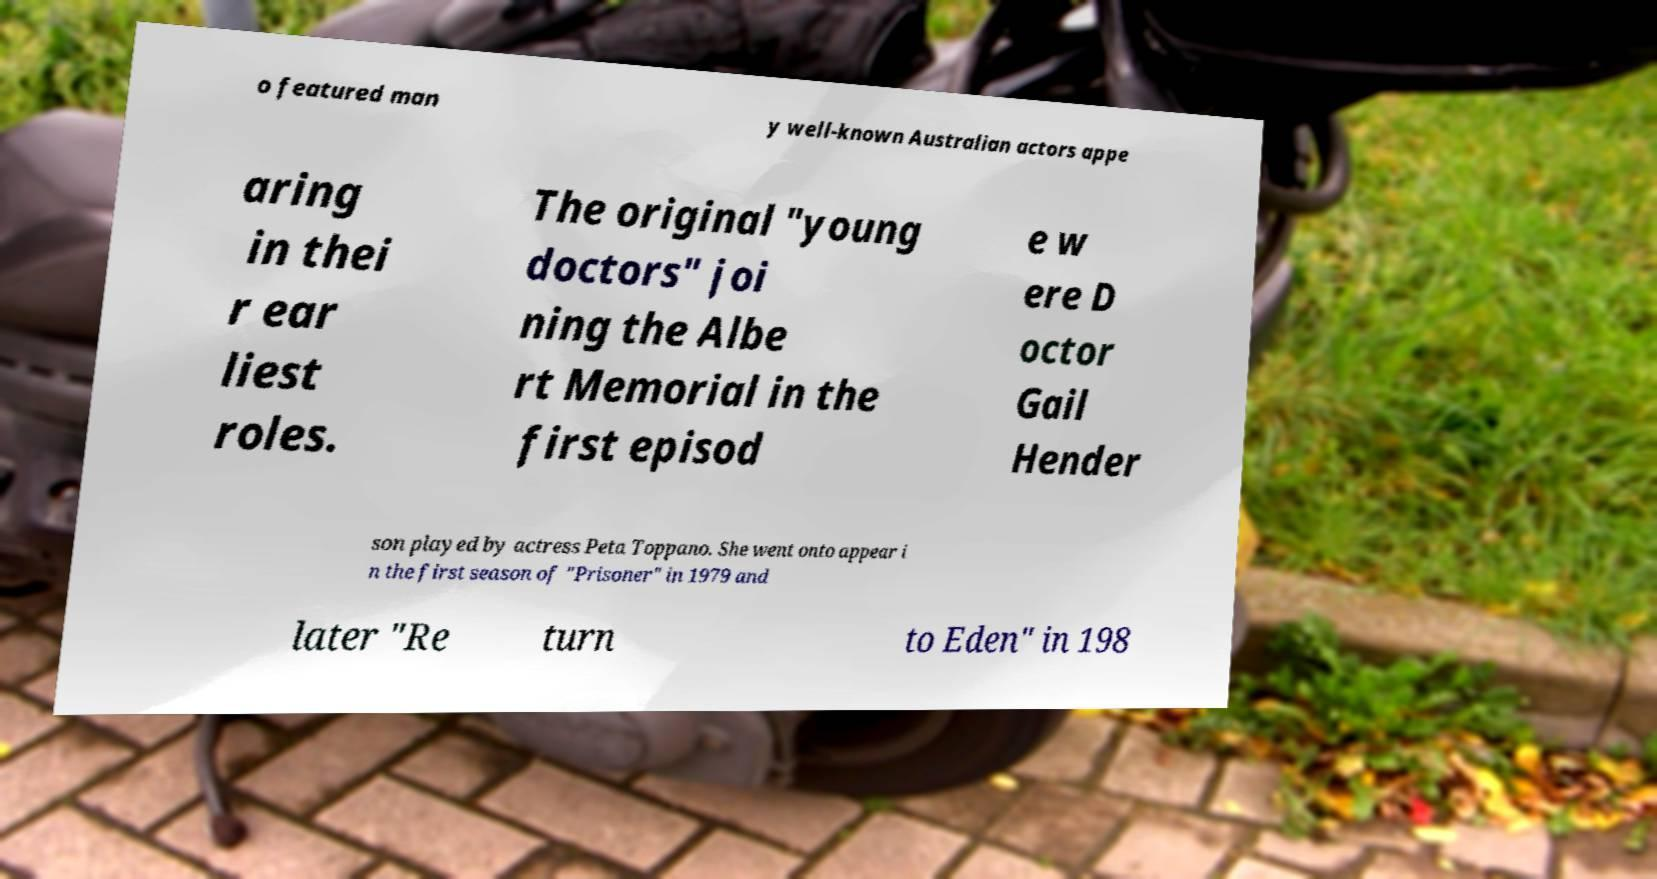Can you accurately transcribe the text from the provided image for me? o featured man y well-known Australian actors appe aring in thei r ear liest roles. The original "young doctors" joi ning the Albe rt Memorial in the first episod e w ere D octor Gail Hender son played by actress Peta Toppano. She went onto appear i n the first season of "Prisoner" in 1979 and later "Re turn to Eden" in 198 